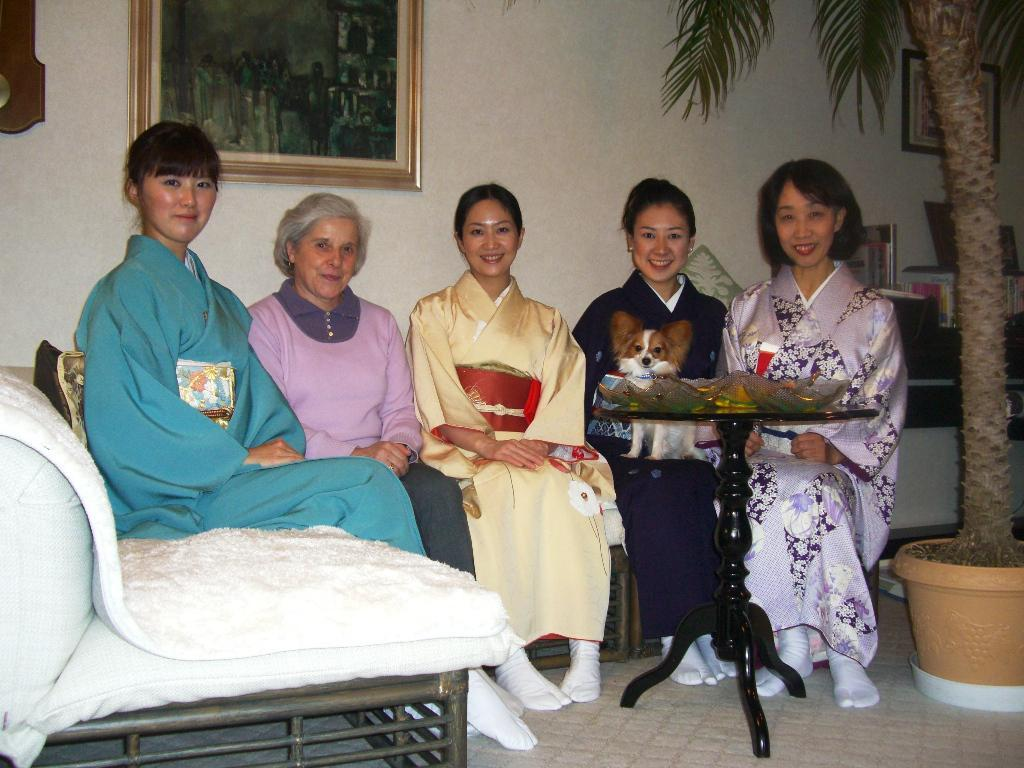What are the people in the image doing? The people in the image are sitting on a sofa. What can be seen outside in the image? There is a tree in the image. What objects are present in the room? There is a pot, a table, and a photo frame in the image. What is the color of the wall in the image? The wall in the image is white. What type of stitch is being used to sew the frog in the image? There is no frog or stitching present in the image. What type of drink is being served on the table in the image? There is no drink visible on the table in the image. 